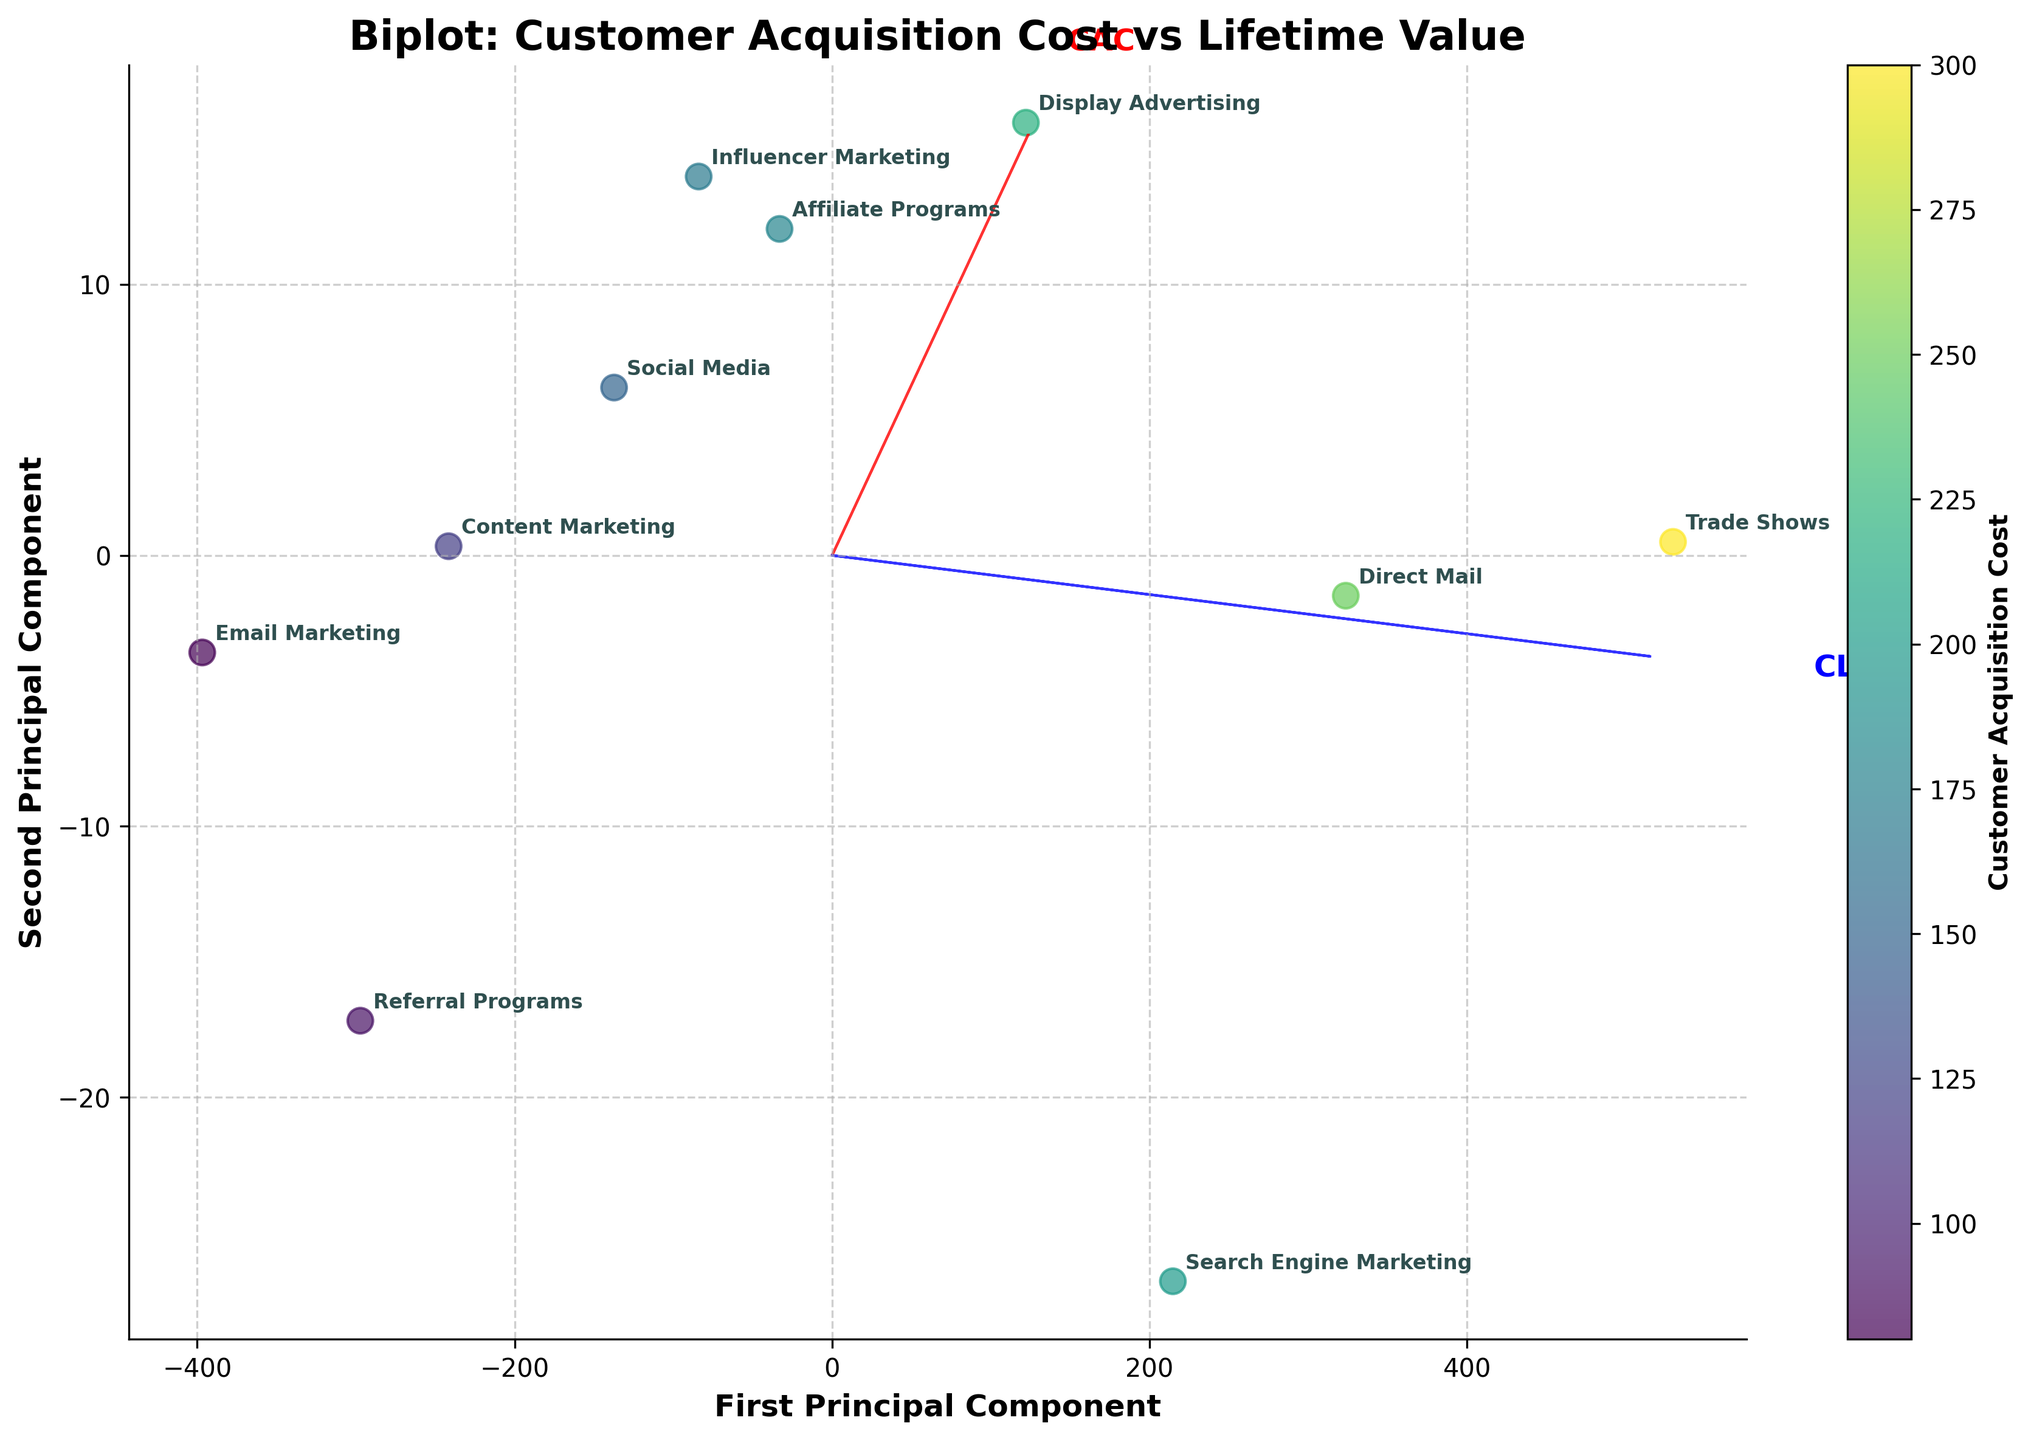How many marketing channels are represented in the biplot? To determine the number of marketing channels, count the individual data points labeled on the biplot. Each label represents an individual marketing channel.
Answer: 10 Which marketing channel has the highest Customer Acquisition Cost (CAC)? To find the marketing channel with the highest CAC, identify the data point with the darkest color shade (since the color bar indicates that darker shades represent higher CAC). The label adjacent to this point represents the corresponding marketing channel.
Answer: Trade Shows Which two marketing channels have the closest Customer Acquisition Costs? By observing the color shades of the data points, identify two points with similar colors. Additionally, ensure that their relative positions on the biplot are close for verification.
Answer: Social Media and Influencer Marketing What do the red and blue arrows represent? The red and blue arrows are the feature vectors indicating the principal components. The red arrow represents Customer Acquisition Cost (CAC), and the blue arrow represents Customer Lifetime Value (CLV). These arrows indicate the directions and contributions of these features to the principal components.
Answer: CAC and CLV Which principal component captures more variance in Customer Acquisition Costs? Look at the length and direction of the red arrow relative to the first and second principal components. The longer the arrow in that direction, the more variance it captures.
Answer: First Principal Component Which marketing channel has the highest Customer Lifetime Value (CLV)? Locate the point furthest along the direction of the blue arrow (CLV) by observing their positions on the biplot. The label adjacent to this point represents the corresponding marketing channel.
Answer: Trade Shows What is the approximate range of the first principal component values? Examine the x-axis labeled 'First Principal Component' and observe the spread of data points. Estimate the minimum and maximum values based on their positions.
Answer: Approximately -500 to 600 Which marketing channel has a lower acquisition cost but relatively high lifetime value? Identify a data point with a lighter color shade (indicating lower acquisition cost) that is positioned relatively further along the direction of the blue arrow (high CLV).
Answer: Email Marketing Is there any marketing channel with a low Customer Acquisition Cost and low Customer Lifetime Value? Find a data point with a lighter shade (indicating low CAC) and closer to the origin of the biplot or along the direction opposite to the blue arrow (low CLV).
Answer: Referral Programs 